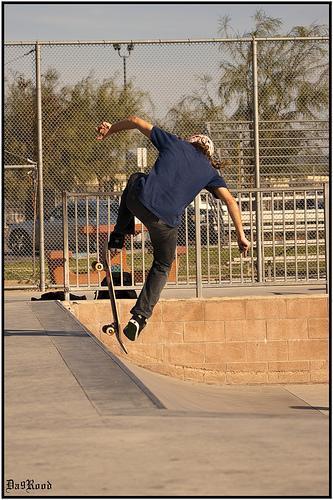How many people are in this photo?
Give a very brief answer. 1. How many cars are in the photo?
Give a very brief answer. 1. 